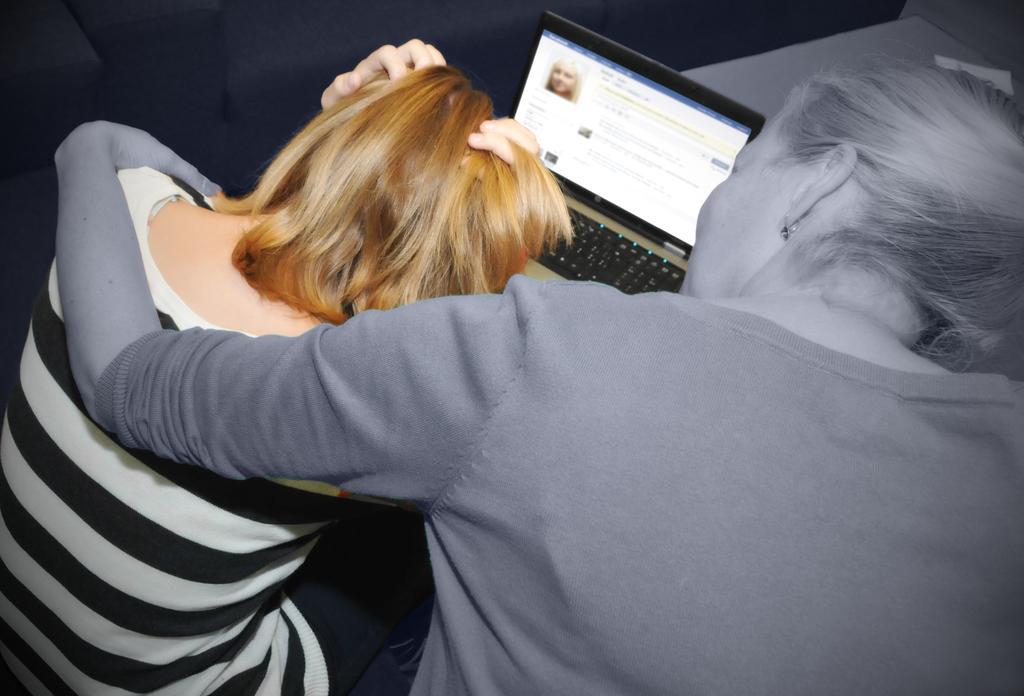How would you summarize this image in a sentence or two? In this image I can see two women are sitting. I can also see a laptop over there and on its screen I can see a face of a person. 